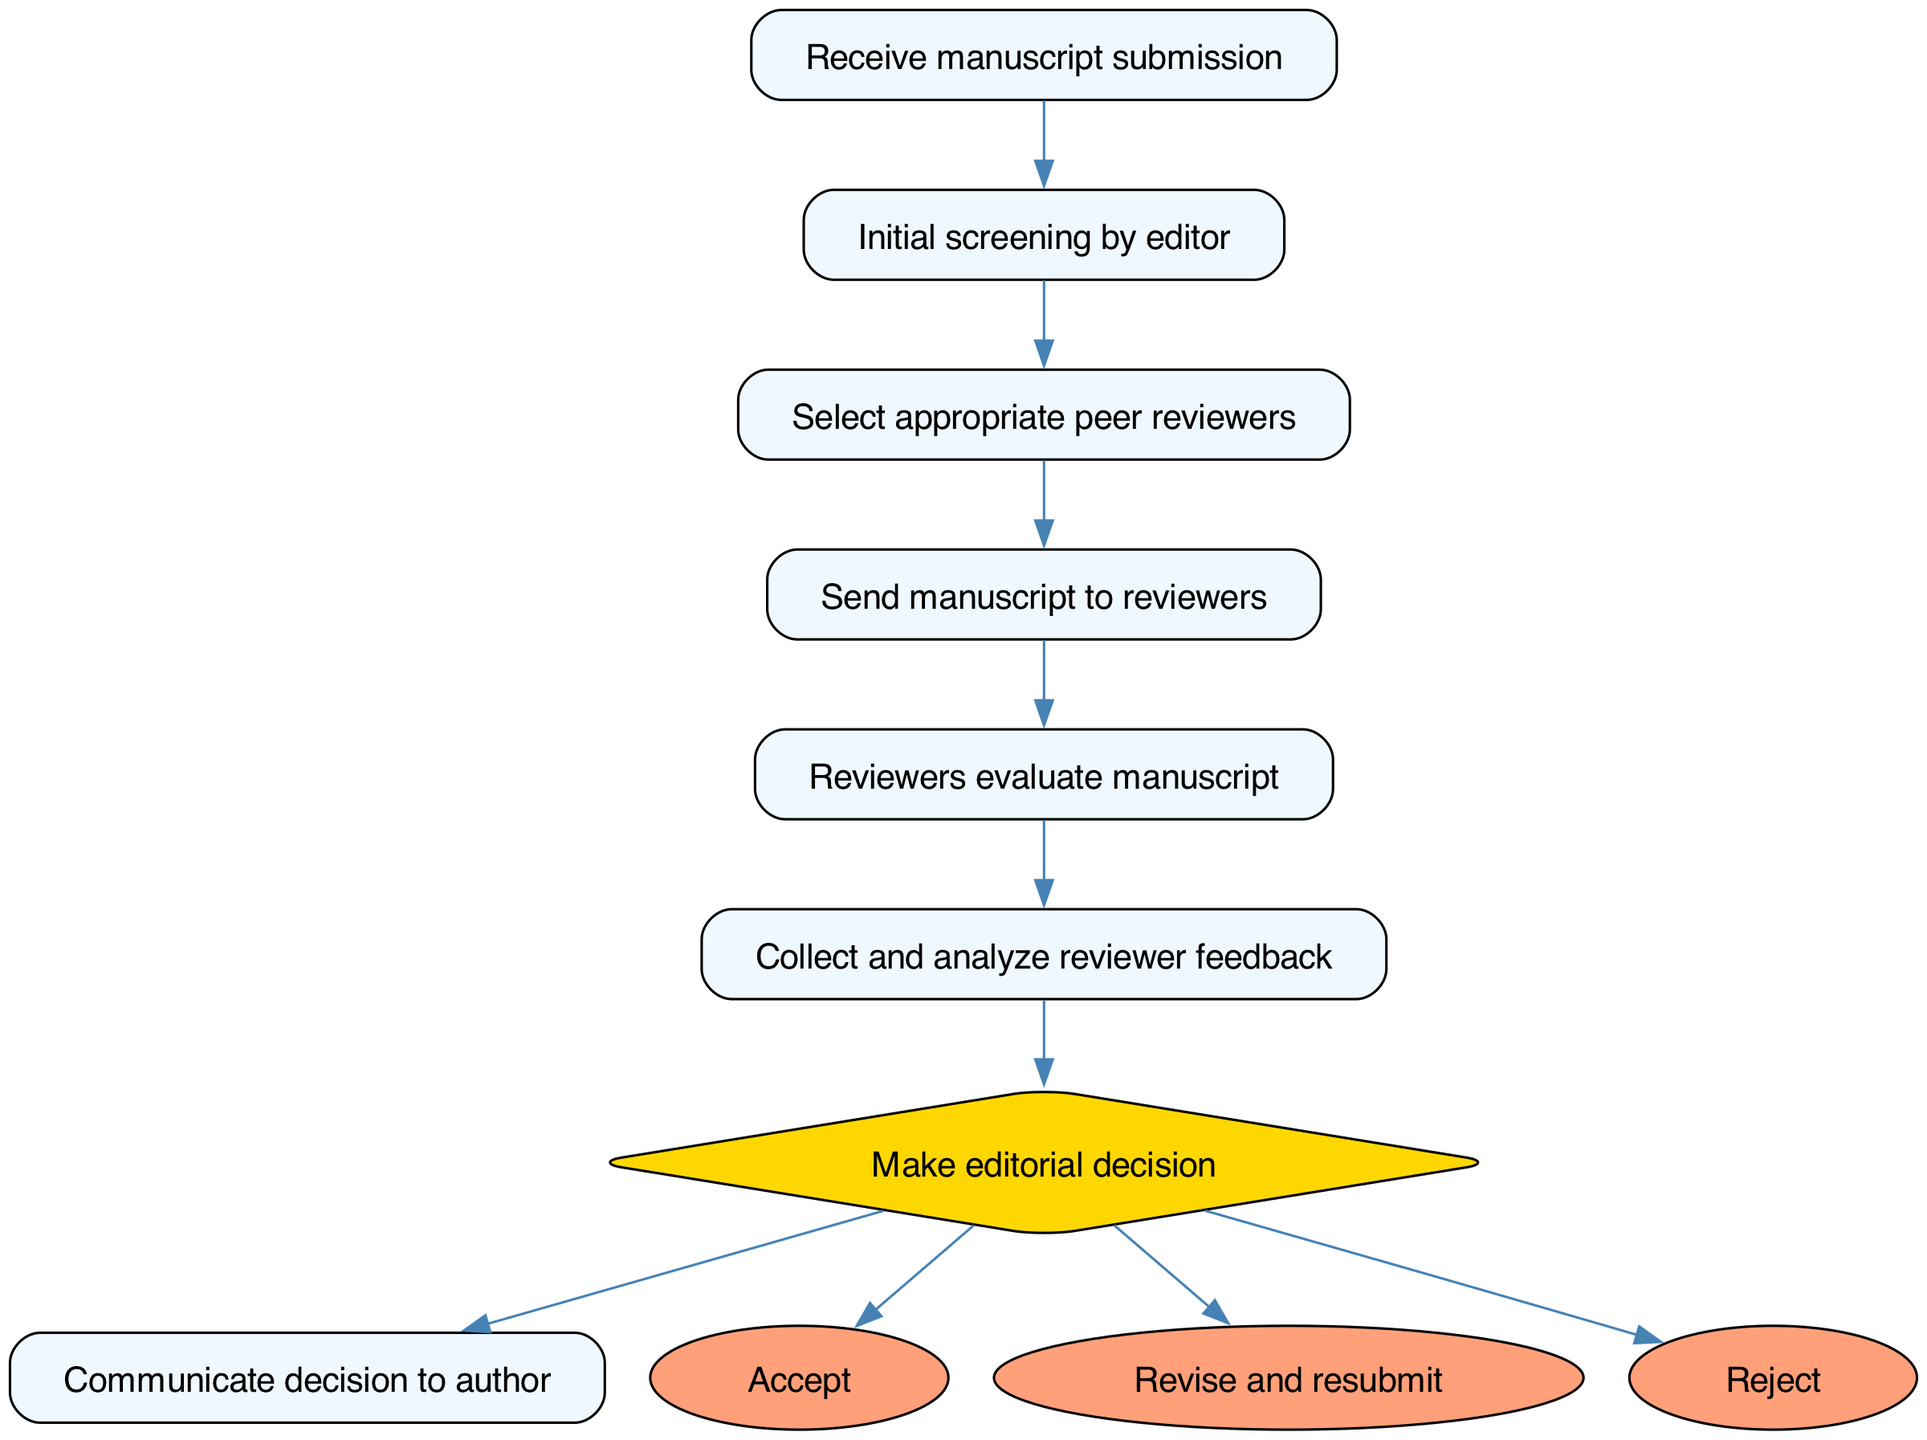What is the first step in the peer review process? The first step is represented by the start node, which is "Receive manuscript submission." This node indicates the initial action taken in the workflow.
Answer: Receive manuscript submission How many nodes are there in total? The total number of nodes includes the start node and all other nodes listed in the diagram. Counting all the nodes gives a total of eight nodes.
Answer: 8 What decision can be made after collecting reviewer feedback? After collecting and analyzing reviewer feedback, the decision-making node provides three options: "Accept," "Revise and resubmit," or "Reject." These are the possible outcomes of the editorial decision.
Answer: Accept, Revise and resubmit, Reject Which node comes immediately after "Send manuscript to reviewers"? The edge directed from "Send manuscript to reviewers" connects to the next node, which is "Reviewers evaluate manuscript." This indicates the sequence of actions in the peer review process.
Answer: Reviewers evaluate manuscript What happens after the initial screening by the editor? After the initial screening by the editor, the process moves to "Select appropriate peer reviewers." This indicates the progression of the workflow after the editor's review of the manuscript.
Answer: Select appropriate peer reviewers What is the relationship between "Reviewers evaluate manuscript" and "Collect and analyze reviewer feedback"? The edge from "Reviewers evaluate manuscript" to "Collect and analyze reviewer feedback" indicates a direct relationship where reviewer evaluations lead to the collection and analysis of their feedback.
Answer: Direct relationship What color is used for the decision-making node? The decision-making node is colored in golden yellow, which visually distinguishes it from the other nodes and indicates its function in the workflow.
Answer: Golden yellow How many options does the editorial decision node offer? The editorial decision node offers three options: "Accept," "Revise and resubmit," and "Reject," showcasing the possible outcomes of the peer review process.
Answer: 3 What step follows "Make editorial decision"? Following "Make editorial decision," the next step is to "Communicate decision to author." This indicates the final action of informing the author about the editorial decision made.
Answer: Communicate decision to author 